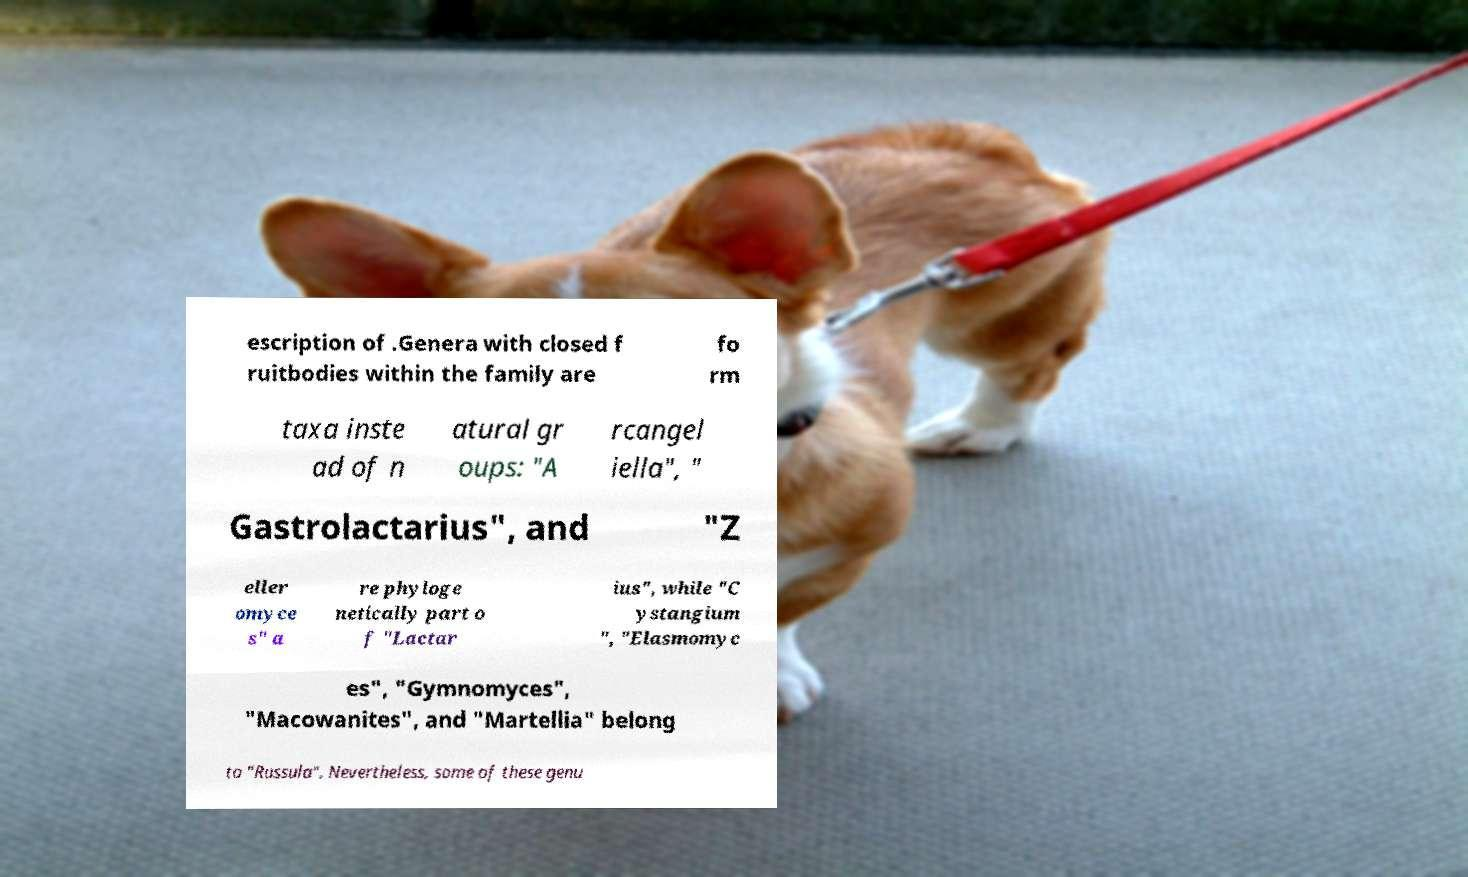Can you accurately transcribe the text from the provided image for me? escription of .Genera with closed f ruitbodies within the family are fo rm taxa inste ad of n atural gr oups: "A rcangel iella", " Gastrolactarius", and "Z eller omyce s" a re phyloge netically part o f "Lactar ius", while "C ystangium ", "Elasmomyc es", "Gymnomyces", "Macowanites", and "Martellia" belong to "Russula". Nevertheless, some of these genu 